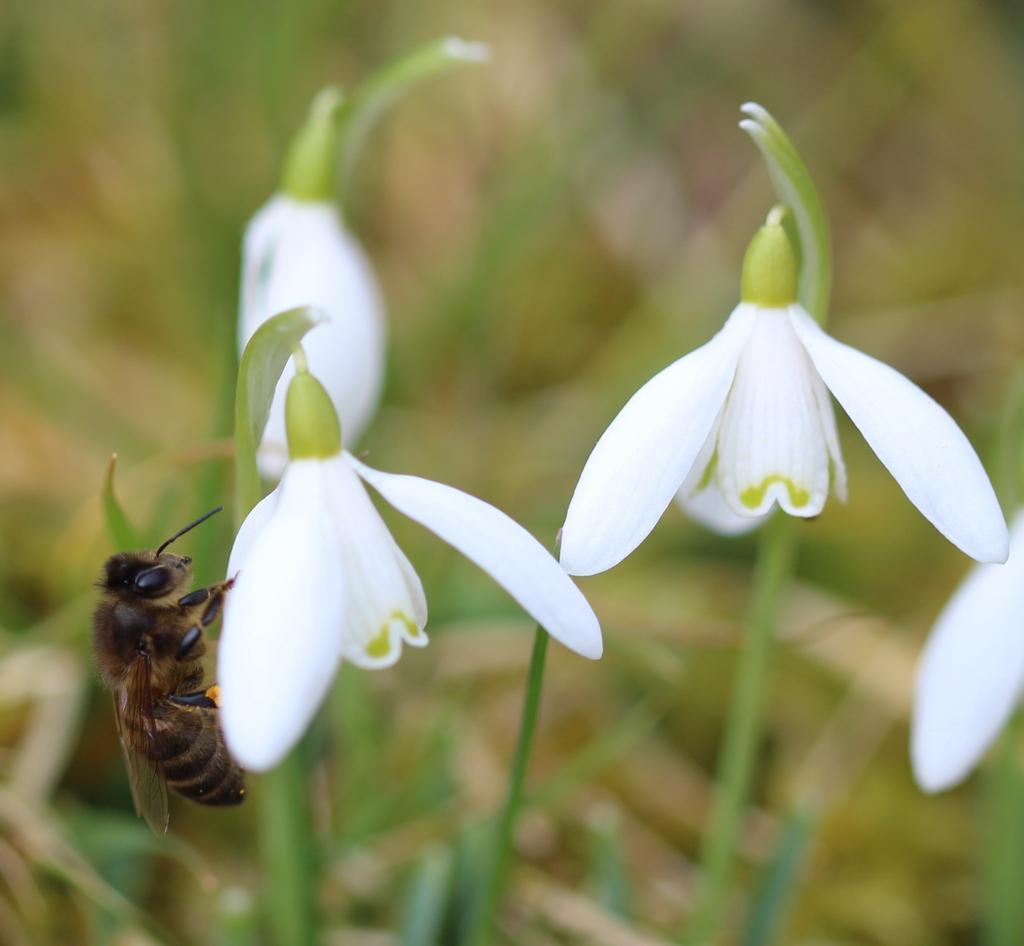Could you give a brief overview of what you see in this image? There are white color flowers. On the flower there is an insect. In the background it is blurred. 